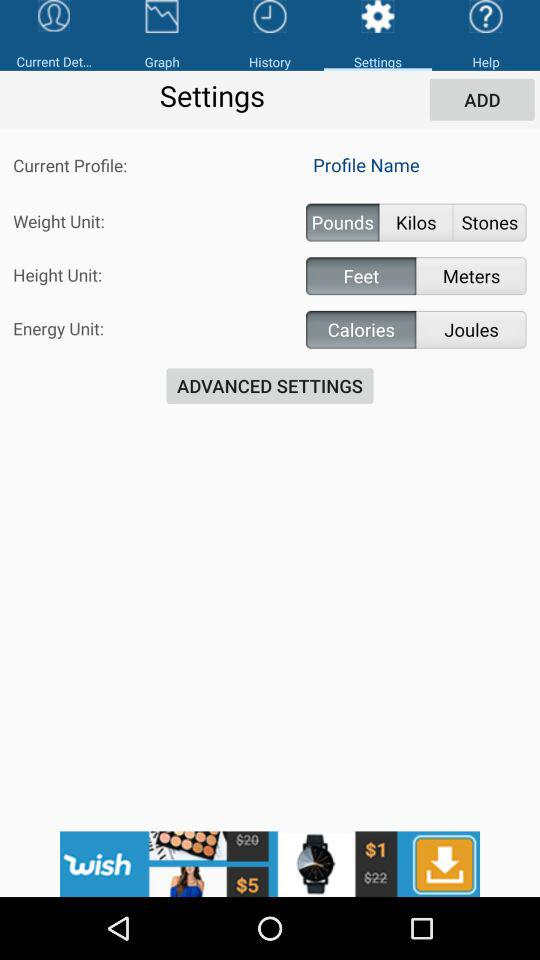What is the weight unit? The weight unit is pounds. 